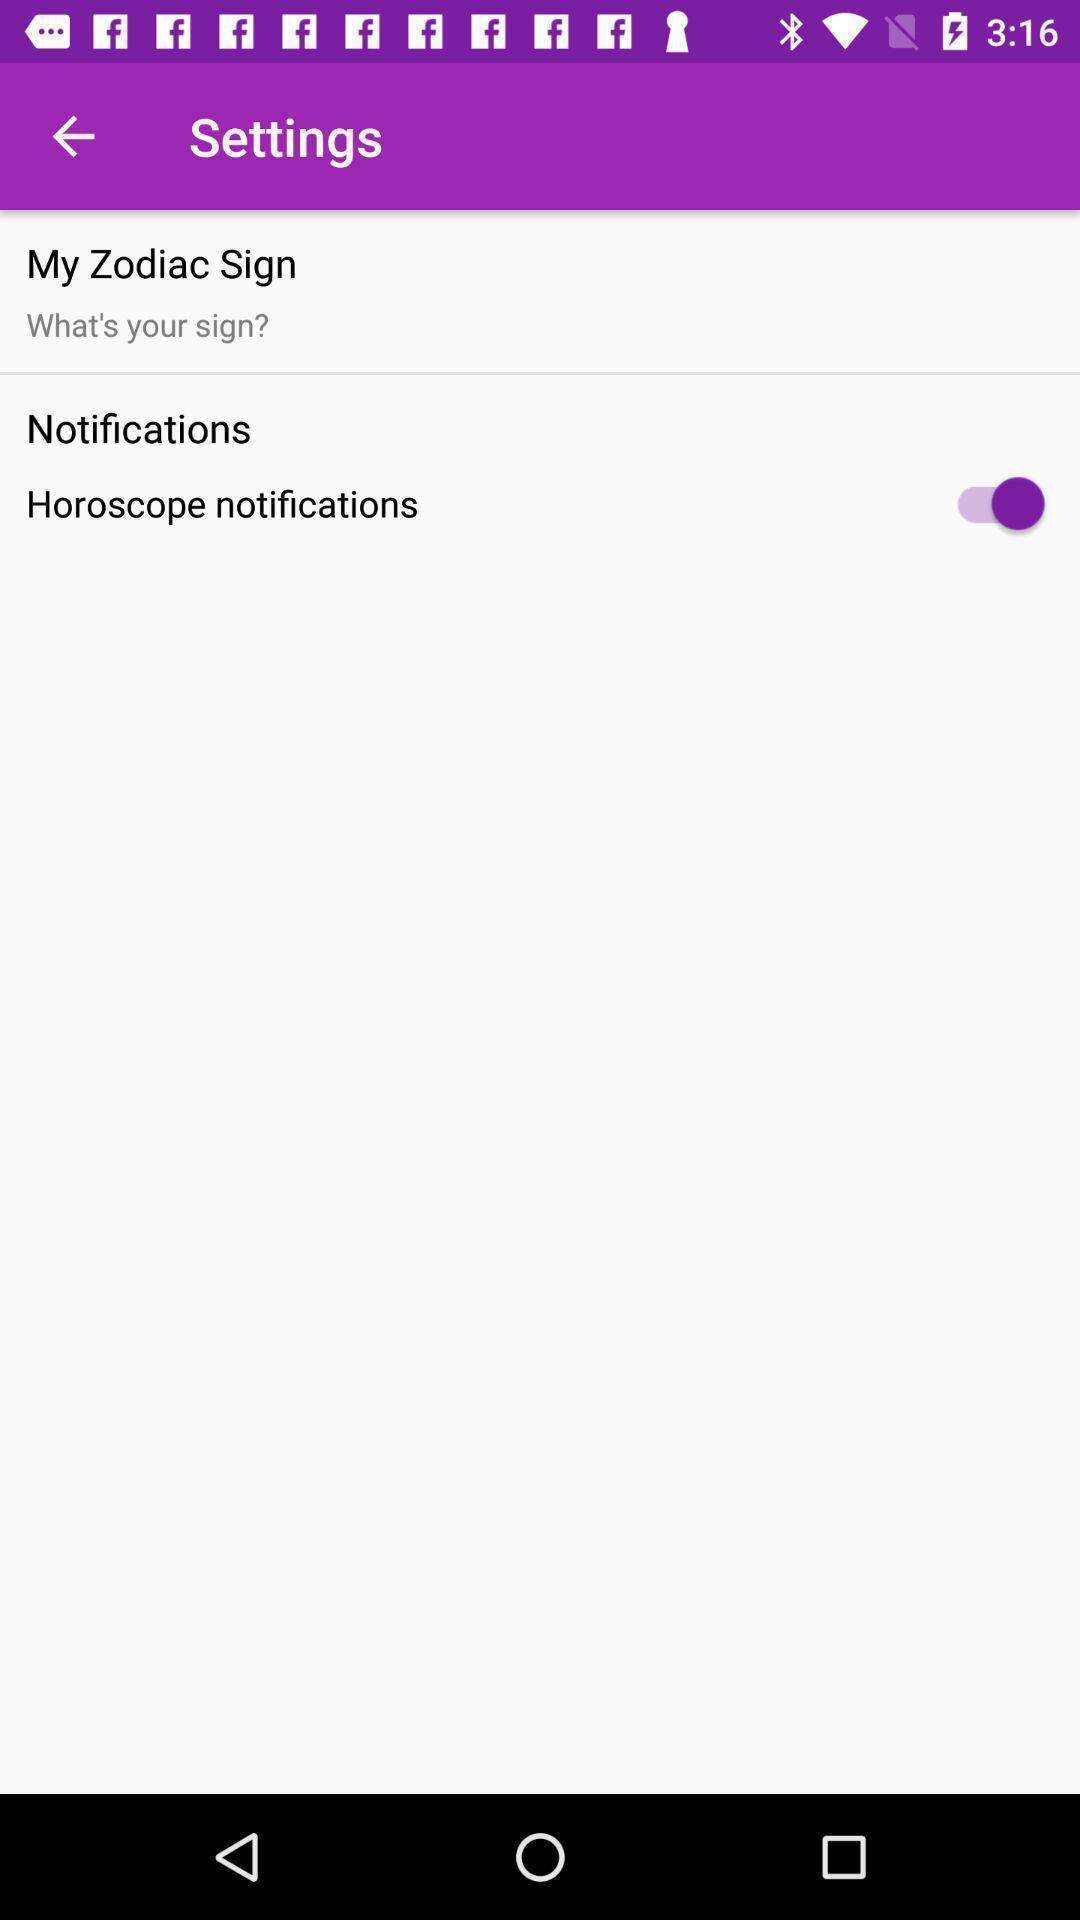Explain the elements present in this screenshot. Screen shows settings on zodiac sign. 